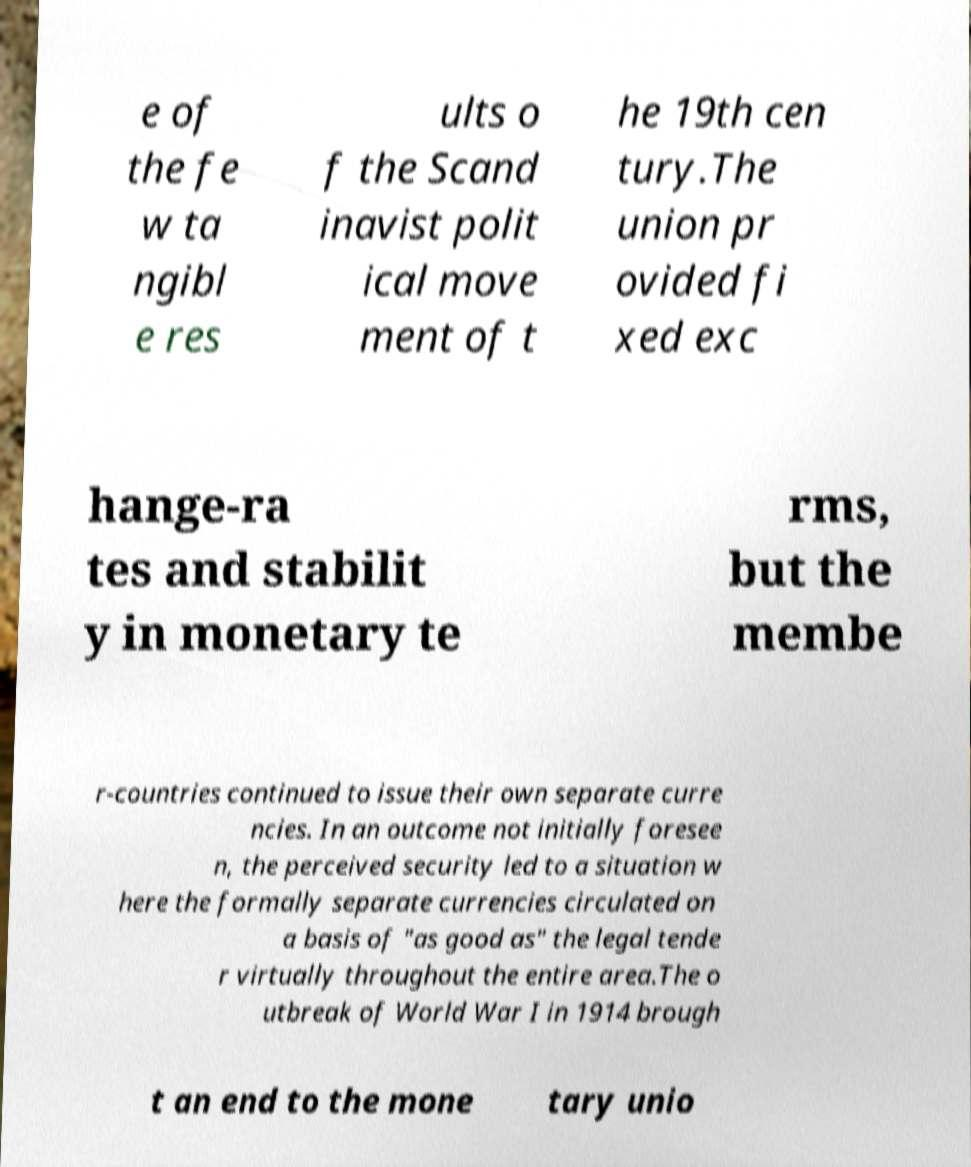There's text embedded in this image that I need extracted. Can you transcribe it verbatim? e of the fe w ta ngibl e res ults o f the Scand inavist polit ical move ment of t he 19th cen tury.The union pr ovided fi xed exc hange-ra tes and stabilit y in monetary te rms, but the membe r-countries continued to issue their own separate curre ncies. In an outcome not initially foresee n, the perceived security led to a situation w here the formally separate currencies circulated on a basis of "as good as" the legal tende r virtually throughout the entire area.The o utbreak of World War I in 1914 brough t an end to the mone tary unio 